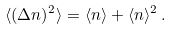Convert formula to latex. <formula><loc_0><loc_0><loc_500><loc_500>\langle ( \Delta n ) ^ { 2 } \rangle = \langle n \rangle + \langle n \rangle ^ { 2 } \, .</formula> 